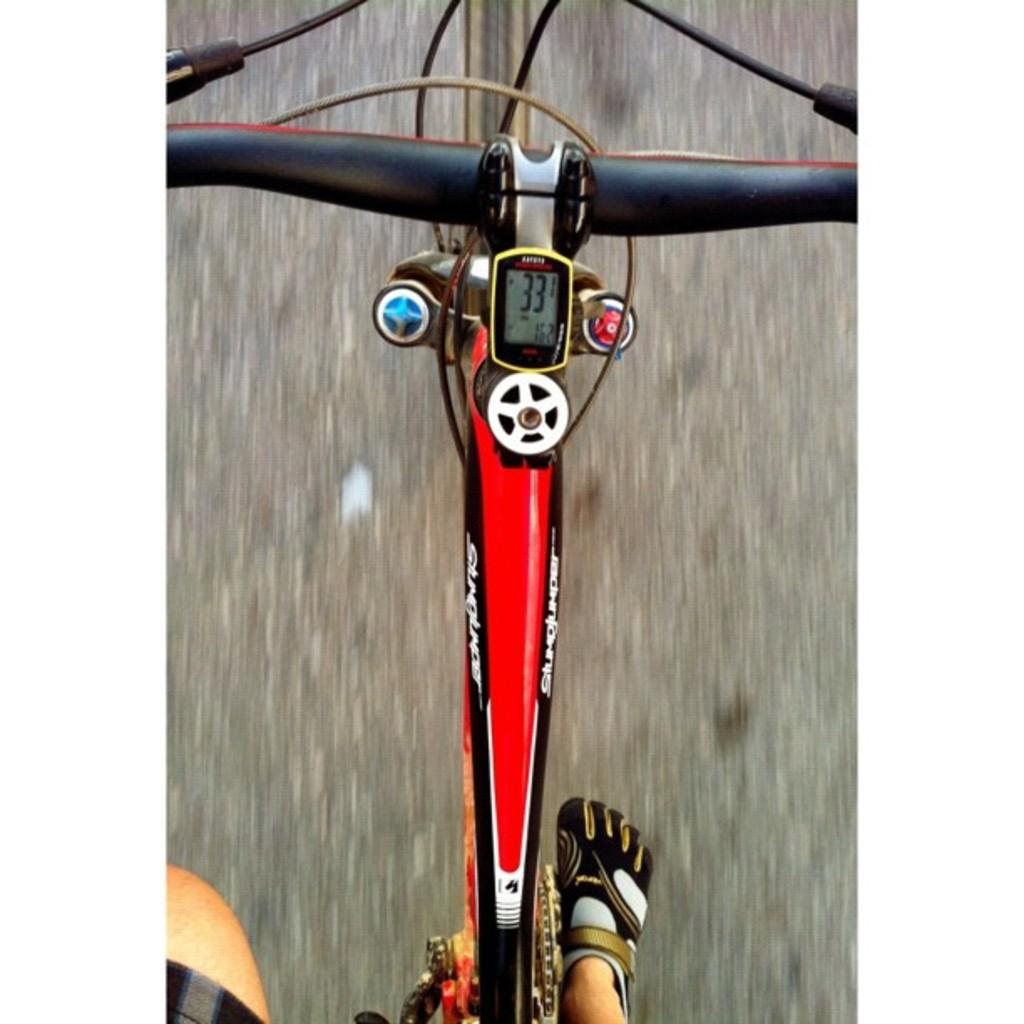What is the main subject of the image? There is a person riding a bicycle in the image. What device is visible on the bicycle? There is a speedometer visible in the image. What can be seen in the background of the image? There is a road in the background of the image. What type of eggnog is being served in the image? A: There is no eggnog present in the image; it features a person riding a bicycle with a visible speedometer and a road in the background. What color are the jeans the person is wearing in the image? There is no information about the person's clothing in the image. 